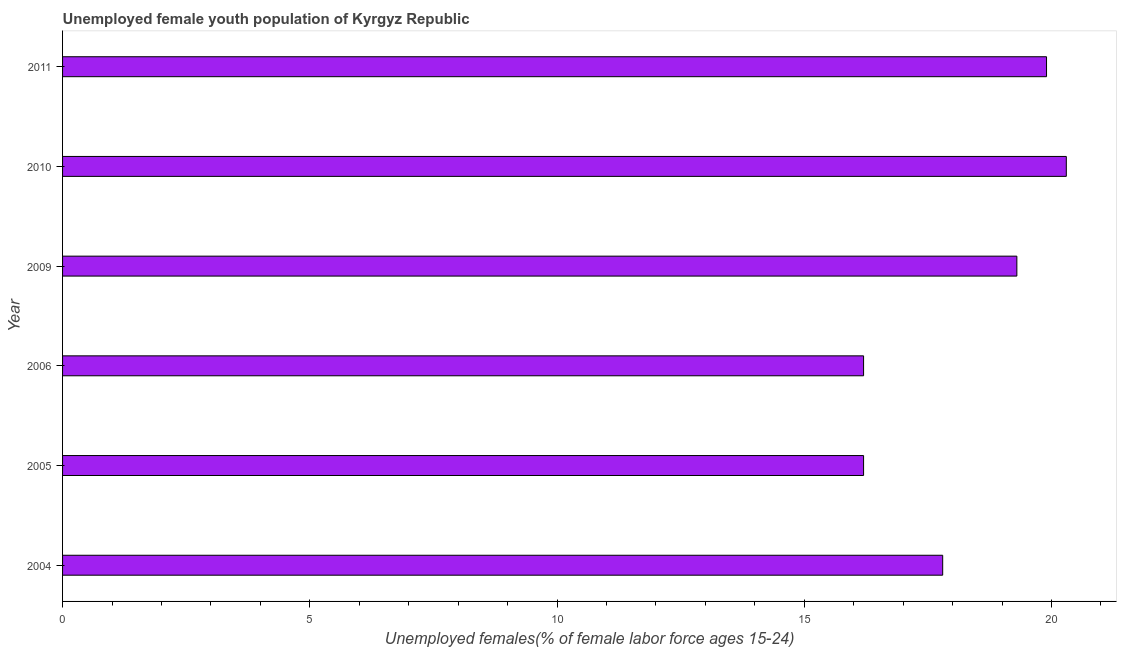Does the graph contain any zero values?
Your response must be concise. No. What is the title of the graph?
Your response must be concise. Unemployed female youth population of Kyrgyz Republic. What is the label or title of the X-axis?
Provide a short and direct response. Unemployed females(% of female labor force ages 15-24). What is the unemployed female youth in 2010?
Make the answer very short. 20.3. Across all years, what is the maximum unemployed female youth?
Offer a terse response. 20.3. Across all years, what is the minimum unemployed female youth?
Give a very brief answer. 16.2. What is the sum of the unemployed female youth?
Offer a terse response. 109.7. What is the difference between the unemployed female youth in 2006 and 2009?
Provide a succinct answer. -3.1. What is the average unemployed female youth per year?
Provide a succinct answer. 18.28. What is the median unemployed female youth?
Provide a short and direct response. 18.55. What is the ratio of the unemployed female youth in 2004 to that in 2010?
Your response must be concise. 0.88. Is the difference between the unemployed female youth in 2010 and 2011 greater than the difference between any two years?
Your response must be concise. No. What is the difference between the highest and the second highest unemployed female youth?
Your answer should be compact. 0.4. Is the sum of the unemployed female youth in 2006 and 2011 greater than the maximum unemployed female youth across all years?
Your answer should be very brief. Yes. What is the difference between the highest and the lowest unemployed female youth?
Provide a short and direct response. 4.1. In how many years, is the unemployed female youth greater than the average unemployed female youth taken over all years?
Keep it short and to the point. 3. How many bars are there?
Your answer should be compact. 6. Are all the bars in the graph horizontal?
Keep it short and to the point. Yes. How many years are there in the graph?
Keep it short and to the point. 6. What is the difference between two consecutive major ticks on the X-axis?
Make the answer very short. 5. What is the Unemployed females(% of female labor force ages 15-24) of 2004?
Provide a short and direct response. 17.8. What is the Unemployed females(% of female labor force ages 15-24) of 2005?
Keep it short and to the point. 16.2. What is the Unemployed females(% of female labor force ages 15-24) in 2006?
Provide a succinct answer. 16.2. What is the Unemployed females(% of female labor force ages 15-24) in 2009?
Your answer should be compact. 19.3. What is the Unemployed females(% of female labor force ages 15-24) in 2010?
Ensure brevity in your answer.  20.3. What is the Unemployed females(% of female labor force ages 15-24) in 2011?
Your answer should be compact. 19.9. What is the difference between the Unemployed females(% of female labor force ages 15-24) in 2005 and 2009?
Your answer should be very brief. -3.1. What is the difference between the Unemployed females(% of female labor force ages 15-24) in 2005 and 2011?
Provide a short and direct response. -3.7. What is the difference between the Unemployed females(% of female labor force ages 15-24) in 2006 and 2009?
Your answer should be compact. -3.1. What is the difference between the Unemployed females(% of female labor force ages 15-24) in 2009 and 2010?
Offer a very short reply. -1. What is the difference between the Unemployed females(% of female labor force ages 15-24) in 2009 and 2011?
Offer a terse response. -0.6. What is the difference between the Unemployed females(% of female labor force ages 15-24) in 2010 and 2011?
Provide a short and direct response. 0.4. What is the ratio of the Unemployed females(% of female labor force ages 15-24) in 2004 to that in 2005?
Your answer should be compact. 1.1. What is the ratio of the Unemployed females(% of female labor force ages 15-24) in 2004 to that in 2006?
Make the answer very short. 1.1. What is the ratio of the Unemployed females(% of female labor force ages 15-24) in 2004 to that in 2009?
Ensure brevity in your answer.  0.92. What is the ratio of the Unemployed females(% of female labor force ages 15-24) in 2004 to that in 2010?
Offer a very short reply. 0.88. What is the ratio of the Unemployed females(% of female labor force ages 15-24) in 2004 to that in 2011?
Your answer should be compact. 0.89. What is the ratio of the Unemployed females(% of female labor force ages 15-24) in 2005 to that in 2006?
Provide a short and direct response. 1. What is the ratio of the Unemployed females(% of female labor force ages 15-24) in 2005 to that in 2009?
Provide a succinct answer. 0.84. What is the ratio of the Unemployed females(% of female labor force ages 15-24) in 2005 to that in 2010?
Offer a very short reply. 0.8. What is the ratio of the Unemployed females(% of female labor force ages 15-24) in 2005 to that in 2011?
Your answer should be compact. 0.81. What is the ratio of the Unemployed females(% of female labor force ages 15-24) in 2006 to that in 2009?
Make the answer very short. 0.84. What is the ratio of the Unemployed females(% of female labor force ages 15-24) in 2006 to that in 2010?
Ensure brevity in your answer.  0.8. What is the ratio of the Unemployed females(% of female labor force ages 15-24) in 2006 to that in 2011?
Give a very brief answer. 0.81. What is the ratio of the Unemployed females(% of female labor force ages 15-24) in 2009 to that in 2010?
Your answer should be very brief. 0.95. 